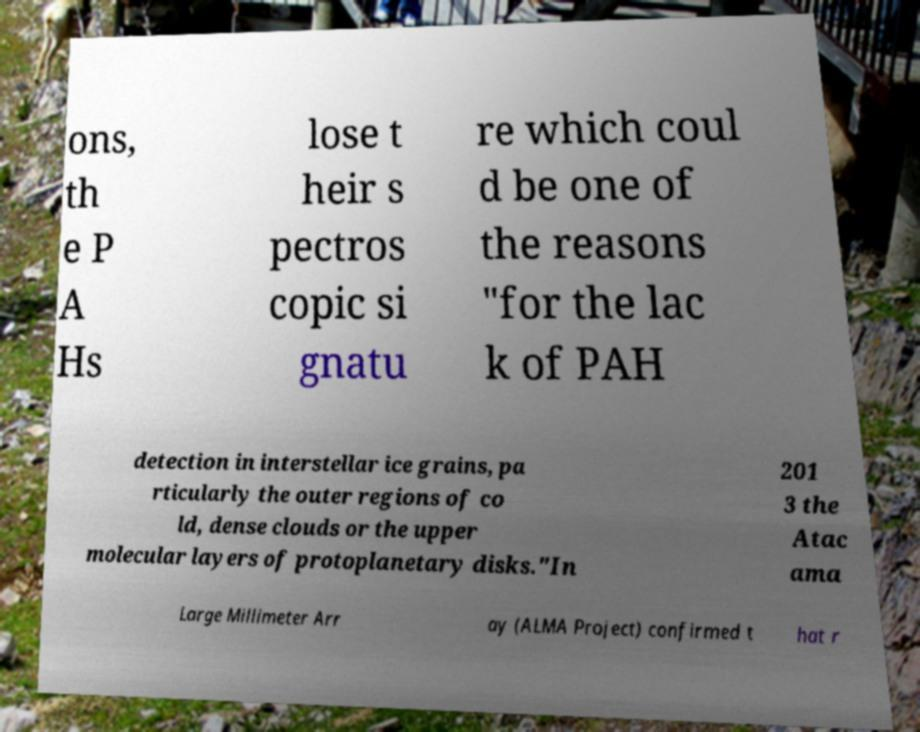Please identify and transcribe the text found in this image. ons, th e P A Hs lose t heir s pectros copic si gnatu re which coul d be one of the reasons "for the lac k of PAH detection in interstellar ice grains, pa rticularly the outer regions of co ld, dense clouds or the upper molecular layers of protoplanetary disks."In 201 3 the Atac ama Large Millimeter Arr ay (ALMA Project) confirmed t hat r 